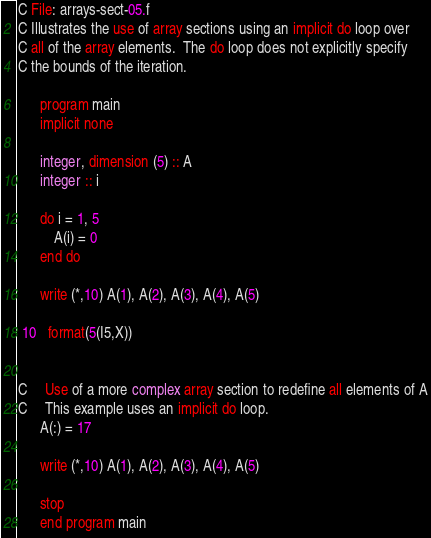Convert code to text. <code><loc_0><loc_0><loc_500><loc_500><_FORTRAN_>C File: arrays-sect-05.f
C Illustrates the use of array sections using an implicit do loop over
C all of the array elements.  The do loop does not explicitly specify
C the bounds of the iteration.

      program main
      implicit none

      integer, dimension (5) :: A
      integer :: i

      do i = 1, 5
          A(i) = 0
      end do

      write (*,10) A(1), A(2), A(3), A(4), A(5)

 10   format(5(I5,X))


C     Use of a more complex array section to redefine all elements of A
C     This example uses an implicit do loop.
      A(:) = 17

      write (*,10) A(1), A(2), A(3), A(4), A(5)

      stop
      end program main

</code> 